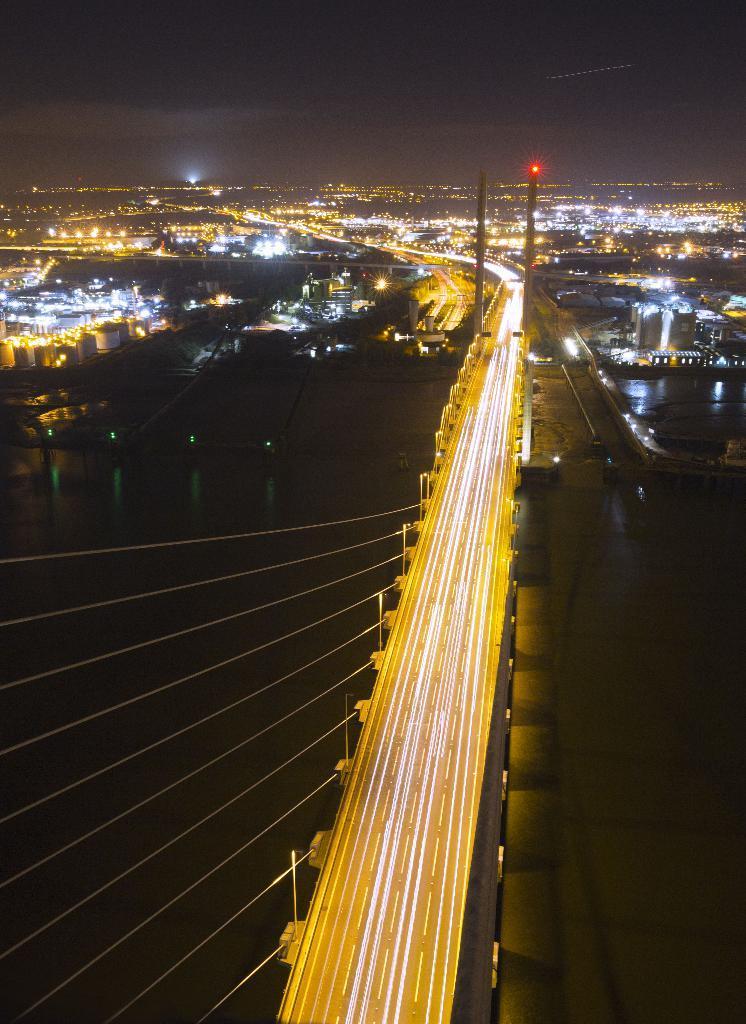Could you give a brief overview of what you see in this image? In this image I can see lights , bridge , poles and the sky. 